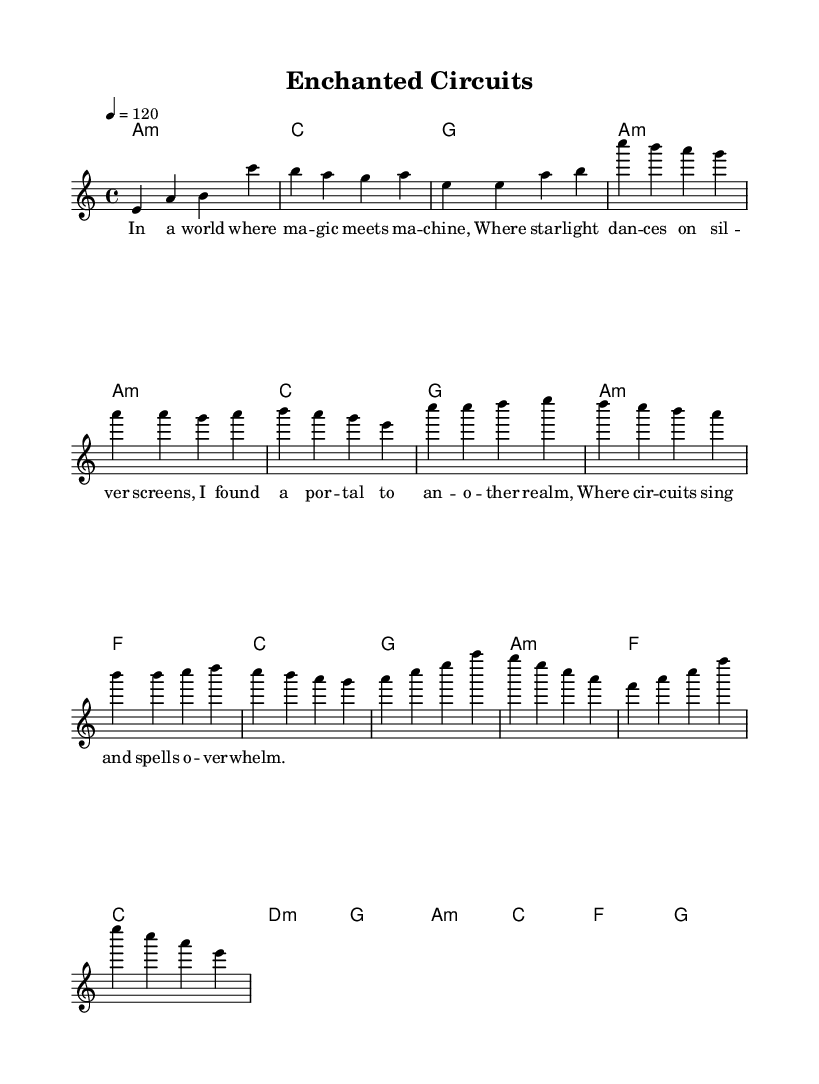What is the key signature of this music? The key signature is A minor, which has no sharps or flats, as indicated at the beginning of the score.
Answer: A minor What is the time signature of this music? The time signature is 4/4, as shown at the start of the score, indicating four beats in each measure.
Answer: 4/4 What is the tempo marking of this piece? The tempo marking is 120 beats per minute, which is specified in the tempo indication at the beginning of the score.
Answer: 120 How many sections are there in this piece? The piece consists of an intro, a verse, a pre-chorus, and a chorus, indicating four distinct sections.
Answer: Four Which section contains the lyrics "Where circuits sing and spells overwhelm"? This lyric appears in the verse section, indicating the context of the material within the song structure.
Answer: Verse What is the progression of harmony in the chorus? The harmony in the chorus follows the progression A minor, C, F, G, as marked in the chord symbols under the melody.
Answer: A minor, C, F, G What is the first note of the melody in the intro? The first note of the melody in the intro is E, as indicated by the musical notation at the start of the score.
Answer: E 